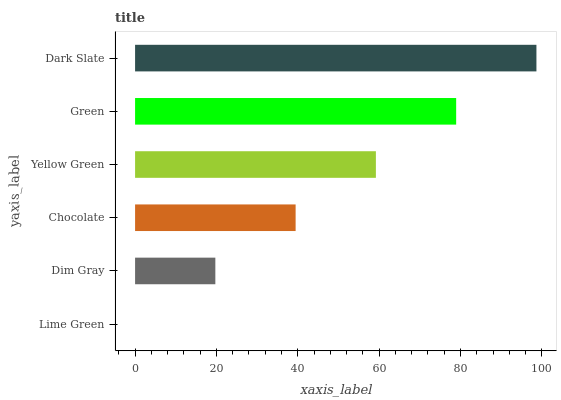Is Lime Green the minimum?
Answer yes or no. Yes. Is Dark Slate the maximum?
Answer yes or no. Yes. Is Dim Gray the minimum?
Answer yes or no. No. Is Dim Gray the maximum?
Answer yes or no. No. Is Dim Gray greater than Lime Green?
Answer yes or no. Yes. Is Lime Green less than Dim Gray?
Answer yes or no. Yes. Is Lime Green greater than Dim Gray?
Answer yes or no. No. Is Dim Gray less than Lime Green?
Answer yes or no. No. Is Yellow Green the high median?
Answer yes or no. Yes. Is Chocolate the low median?
Answer yes or no. Yes. Is Chocolate the high median?
Answer yes or no. No. Is Green the low median?
Answer yes or no. No. 